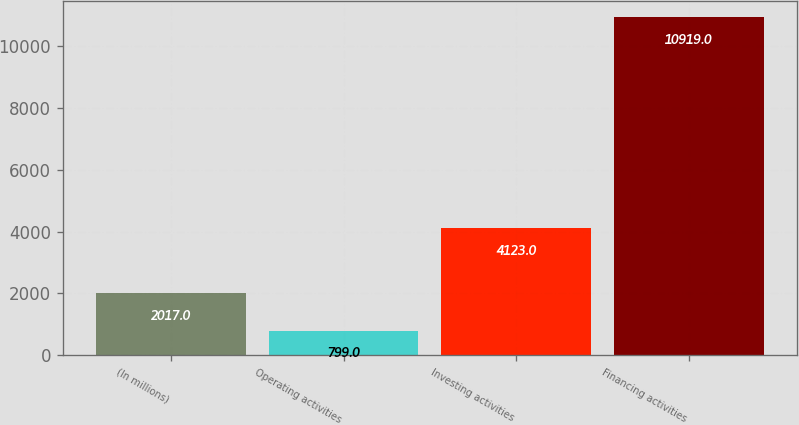<chart> <loc_0><loc_0><loc_500><loc_500><bar_chart><fcel>(In millions)<fcel>Operating activities<fcel>Investing activities<fcel>Financing activities<nl><fcel>2017<fcel>799<fcel>4123<fcel>10919<nl></chart> 